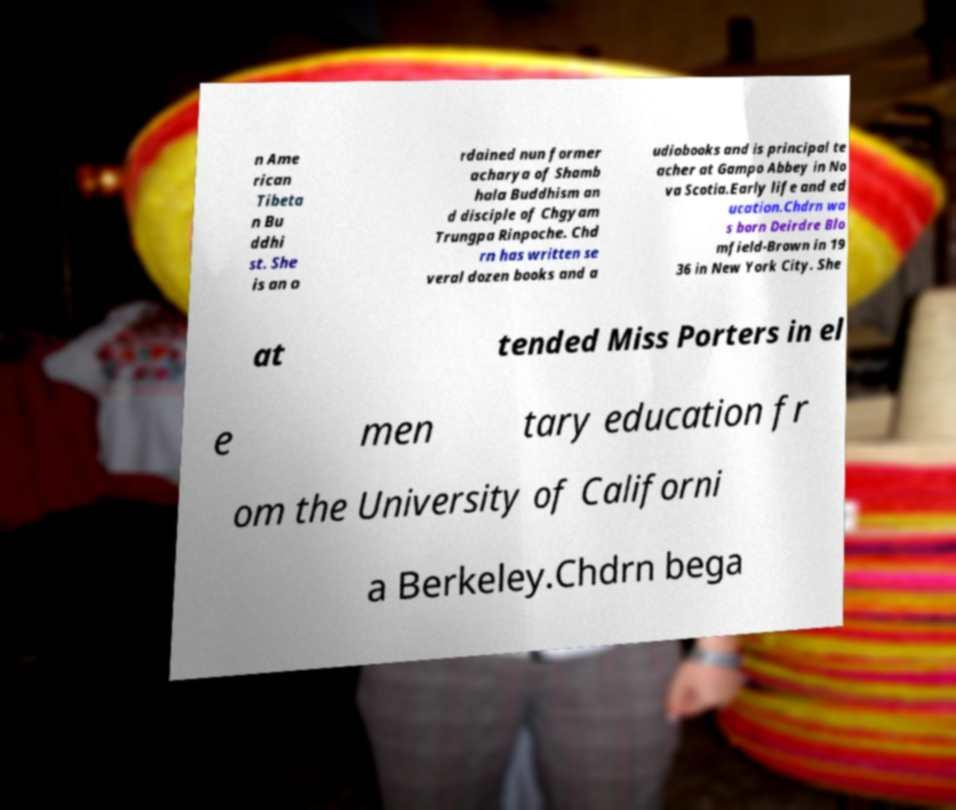There's text embedded in this image that I need extracted. Can you transcribe it verbatim? n Ame rican Tibeta n Bu ddhi st. She is an o rdained nun former acharya of Shamb hala Buddhism an d disciple of Chgyam Trungpa Rinpoche. Chd rn has written se veral dozen books and a udiobooks and is principal te acher at Gampo Abbey in No va Scotia.Early life and ed ucation.Chdrn wa s born Deirdre Blo mfield-Brown in 19 36 in New York City. She at tended Miss Porters in el e men tary education fr om the University of Californi a Berkeley.Chdrn bega 